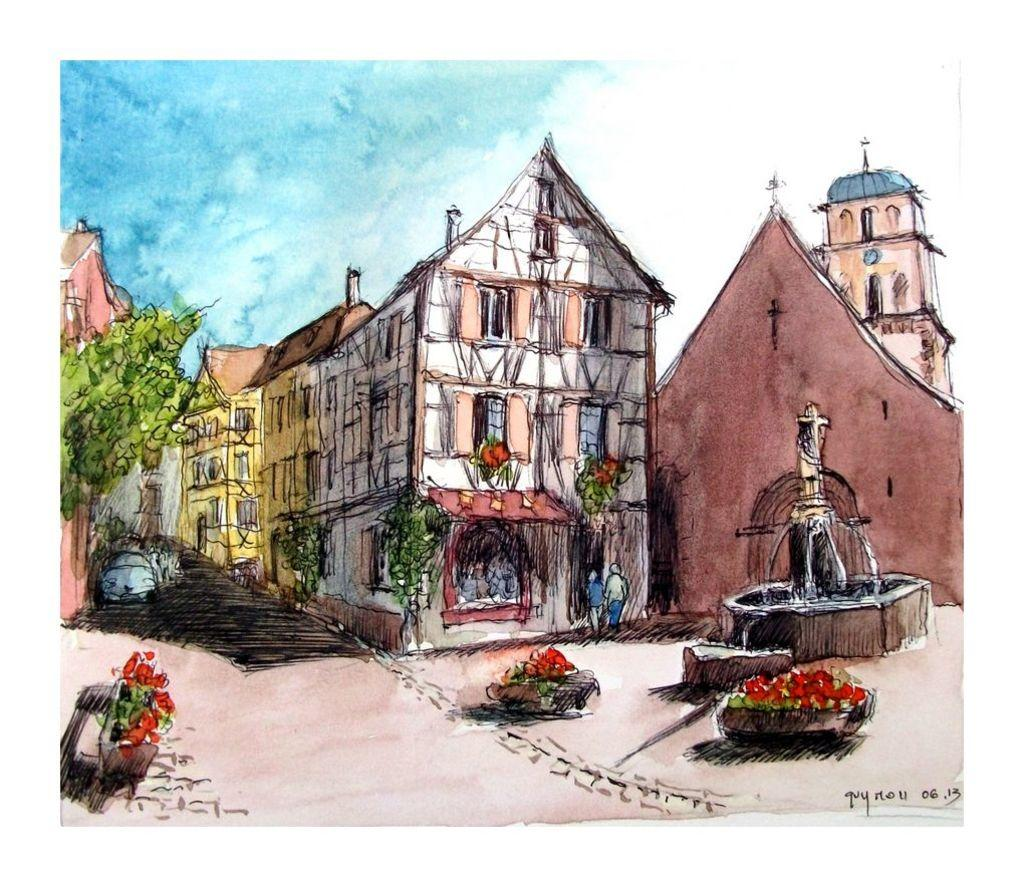What type of structures can be seen in the image? There are buildings in the image. What is a prominent feature in the image? There is a fountain in the image. What type of vegetation is present in the image? There are trees in the image. What type of plants can be seen in the image? There are flowers in the image. What is located at the bottom of the image? There is a walkway at the bottom of the image. What is visible at the top of the image? The sky is visible at the top of the image. What type of jewel is the father holding in the image? There is no father or jewel present in the image. What type of vacation is depicted in the image? The image does not depict a vacation; it shows a scene with buildings, a fountain, trees, flowers, a walkway, and the sky. 